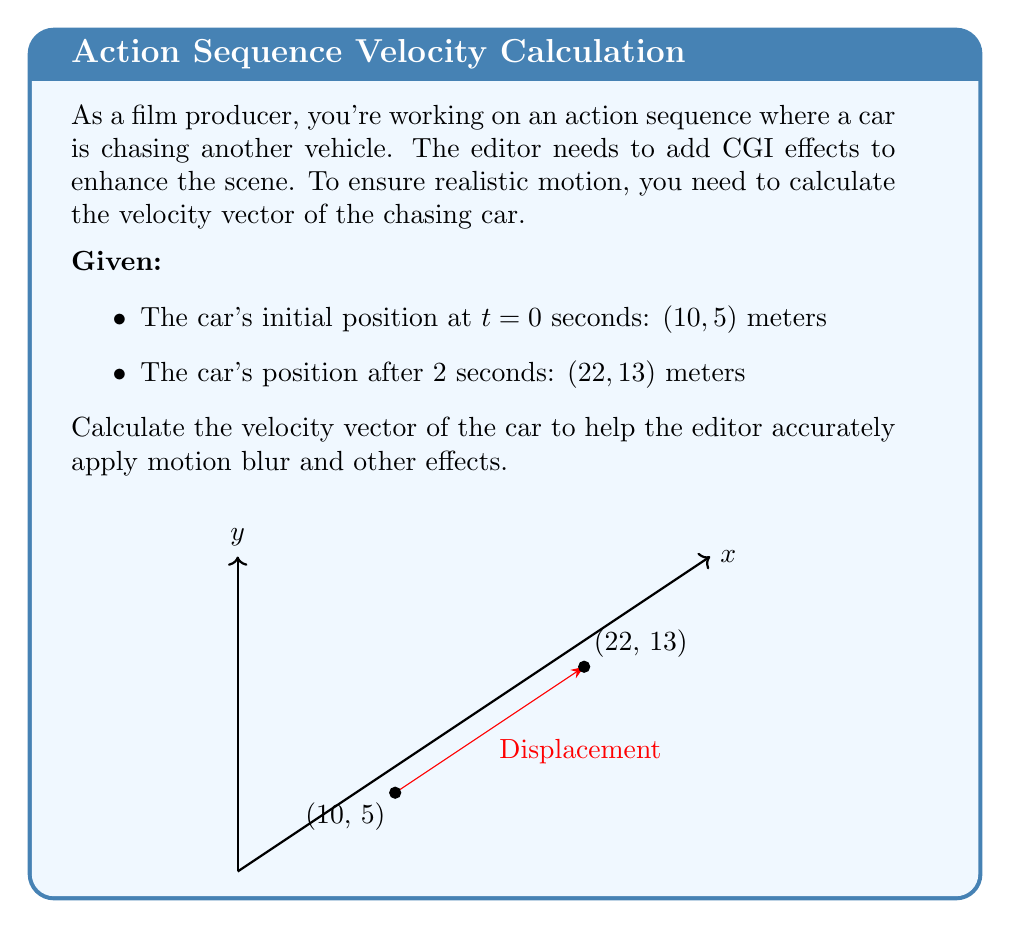Teach me how to tackle this problem. To calculate the velocity vector, we'll follow these steps:

1) First, let's find the displacement vector:
   $$\vec{d} = \vec{r_f} - \vec{r_i} = (22, 13) - (10, 5) = (12, 8)$$ meters

2) The velocity vector is the displacement vector divided by the time interval:
   $$\vec{v} = \frac{\vec{d}}{\Delta t} = \frac{(12, 8)}{2} = (6, 4)$$ meters per second

3) To express this as a single vector:
   $$\vec{v} = 6\hat{i} + 4\hat{j}$$ meters per second

Where $\hat{i}$ is the unit vector in the x-direction and $\hat{j}$ is the unit vector in the y-direction.

4) The magnitude of the velocity vector can be calculated using the Pythagorean theorem:
   $$|\vec{v}| = \sqrt{6^2 + 4^2} = \sqrt{36 + 16} = \sqrt{52} \approx 7.21$$ meters per second

This velocity vector will help the editor apply appropriate motion blur and other effects to create a realistic chase scene.
Answer: $\vec{v} = 6\hat{i} + 4\hat{j}$ m/s 